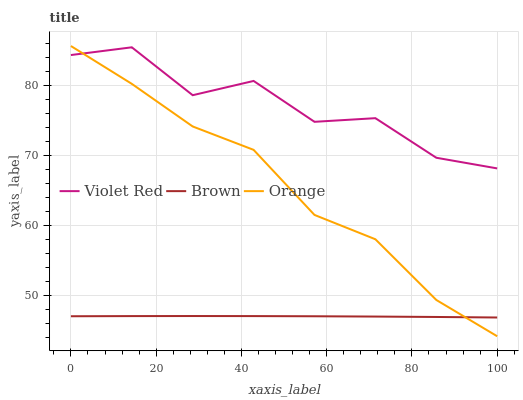Does Violet Red have the minimum area under the curve?
Answer yes or no. No. Does Brown have the maximum area under the curve?
Answer yes or no. No. Is Violet Red the smoothest?
Answer yes or no. No. Is Brown the roughest?
Answer yes or no. No. Does Brown have the lowest value?
Answer yes or no. No. Does Violet Red have the highest value?
Answer yes or no. No. Is Brown less than Violet Red?
Answer yes or no. Yes. Is Violet Red greater than Brown?
Answer yes or no. Yes. Does Brown intersect Violet Red?
Answer yes or no. No. 